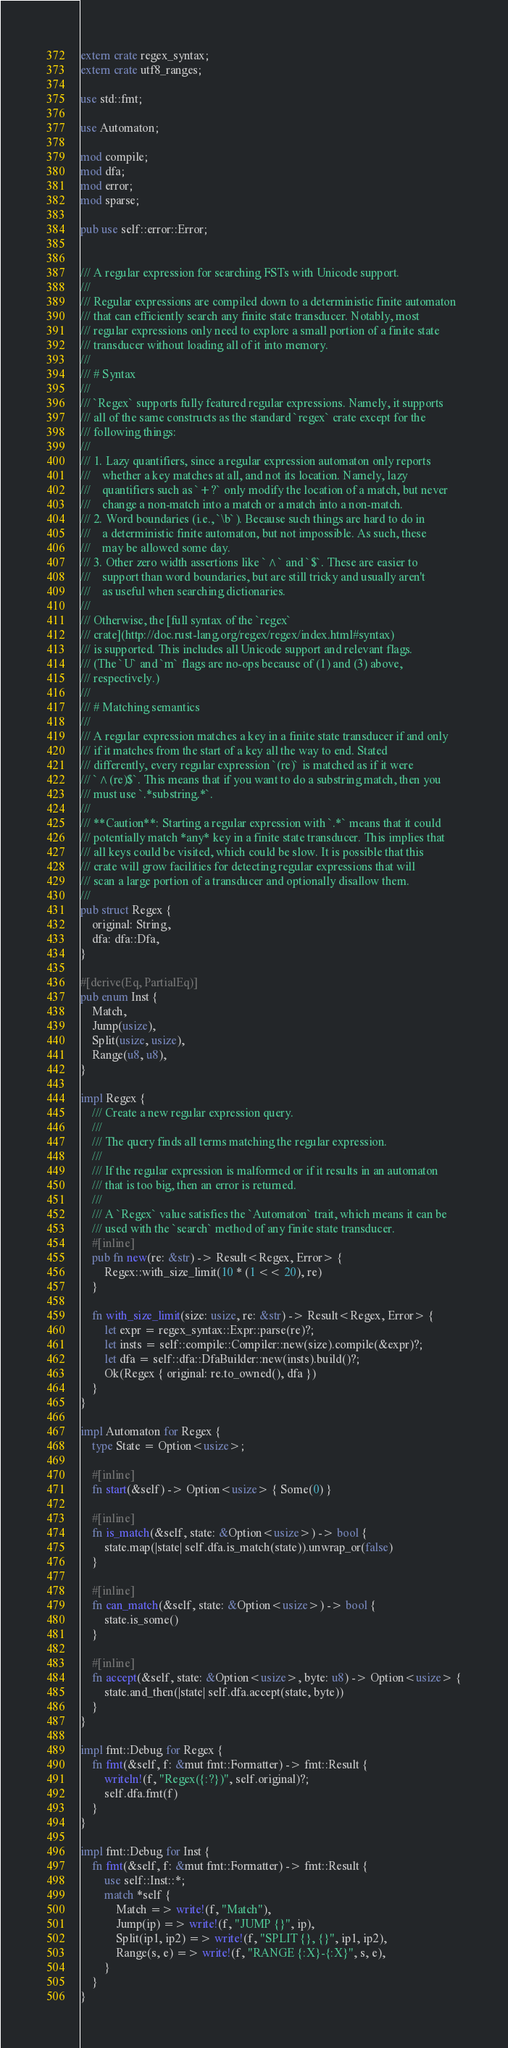Convert code to text. <code><loc_0><loc_0><loc_500><loc_500><_Rust_>extern crate regex_syntax;
extern crate utf8_ranges;

use std::fmt;

use Automaton;

mod compile;
mod dfa;
mod error;
mod sparse;

pub use self::error::Error;


/// A regular expression for searching FSTs with Unicode support.
///
/// Regular expressions are compiled down to a deterministic finite automaton
/// that can efficiently search any finite state transducer. Notably, most
/// regular expressions only need to explore a small portion of a finite state
/// transducer without loading all of it into memory.
///
/// # Syntax
///
/// `Regex` supports fully featured regular expressions. Namely, it supports
/// all of the same constructs as the standard `regex` crate except for the
/// following things:
///
/// 1. Lazy quantifiers, since a regular expression automaton only reports
///    whether a key matches at all, and not its location. Namely, lazy
///    quantifiers such as `+?` only modify the location of a match, but never
///    change a non-match into a match or a match into a non-match.
/// 2. Word boundaries (i.e., `\b`). Because such things are hard to do in
///    a deterministic finite automaton, but not impossible. As such, these
///    may be allowed some day.
/// 3. Other zero width assertions like `^` and `$`. These are easier to
///    support than word boundaries, but are still tricky and usually aren't
///    as useful when searching dictionaries.
///
/// Otherwise, the [full syntax of the `regex`
/// crate](http://doc.rust-lang.org/regex/regex/index.html#syntax)
/// is supported. This includes all Unicode support and relevant flags.
/// (The `U` and `m` flags are no-ops because of (1) and (3) above,
/// respectively.)
///
/// # Matching semantics
///
/// A regular expression matches a key in a finite state transducer if and only
/// if it matches from the start of a key all the way to end. Stated
/// differently, every regular expression `(re)` is matched as if it were
/// `^(re)$`. This means that if you want to do a substring match, then you
/// must use `.*substring.*`.
///
/// **Caution**: Starting a regular expression with `.*` means that it could
/// potentially match *any* key in a finite state transducer. This implies that
/// all keys could be visited, which could be slow. It is possible that this
/// crate will grow facilities for detecting regular expressions that will
/// scan a large portion of a transducer and optionally disallow them.
///
pub struct Regex {
    original: String,
    dfa: dfa::Dfa,
}

#[derive(Eq, PartialEq)]
pub enum Inst {
    Match,
    Jump(usize),
    Split(usize, usize),
    Range(u8, u8),
}

impl Regex {
    /// Create a new regular expression query.
    ///
    /// The query finds all terms matching the regular expression.
    ///
    /// If the regular expression is malformed or if it results in an automaton
    /// that is too big, then an error is returned.
    ///
    /// A `Regex` value satisfies the `Automaton` trait, which means it can be
    /// used with the `search` method of any finite state transducer.
    #[inline]
    pub fn new(re: &str) -> Result<Regex, Error> {
        Regex::with_size_limit(10 * (1 << 20), re)
    }

    fn with_size_limit(size: usize, re: &str) -> Result<Regex, Error> {
        let expr = regex_syntax::Expr::parse(re)?;
        let insts = self::compile::Compiler::new(size).compile(&expr)?;
        let dfa = self::dfa::DfaBuilder::new(insts).build()?;
        Ok(Regex { original: re.to_owned(), dfa })
    }
}

impl Automaton for Regex {
    type State = Option<usize>;

    #[inline]
    fn start(&self) -> Option<usize> { Some(0) }

    #[inline]
    fn is_match(&self, state: &Option<usize>) -> bool {
        state.map(|state| self.dfa.is_match(state)).unwrap_or(false)
    }

    #[inline]
    fn can_match(&self, state: &Option<usize>) -> bool {
        state.is_some()
    }

    #[inline]
    fn accept(&self, state: &Option<usize>, byte: u8) -> Option<usize> {
        state.and_then(|state| self.dfa.accept(state, byte))
    }
}

impl fmt::Debug for Regex {
    fn fmt(&self, f: &mut fmt::Formatter) -> fmt::Result {
        writeln!(f, "Regex({:?})", self.original)?;
        self.dfa.fmt(f)
    }
}

impl fmt::Debug for Inst {
    fn fmt(&self, f: &mut fmt::Formatter) -> fmt::Result {
        use self::Inst::*;
        match *self {
            Match => write!(f, "Match"),
            Jump(ip) => write!(f, "JUMP {}", ip),
            Split(ip1, ip2) => write!(f, "SPLIT {}, {}", ip1, ip2),
            Range(s, e) => write!(f, "RANGE {:X}-{:X}", s, e),
        }
    }
}
</code> 